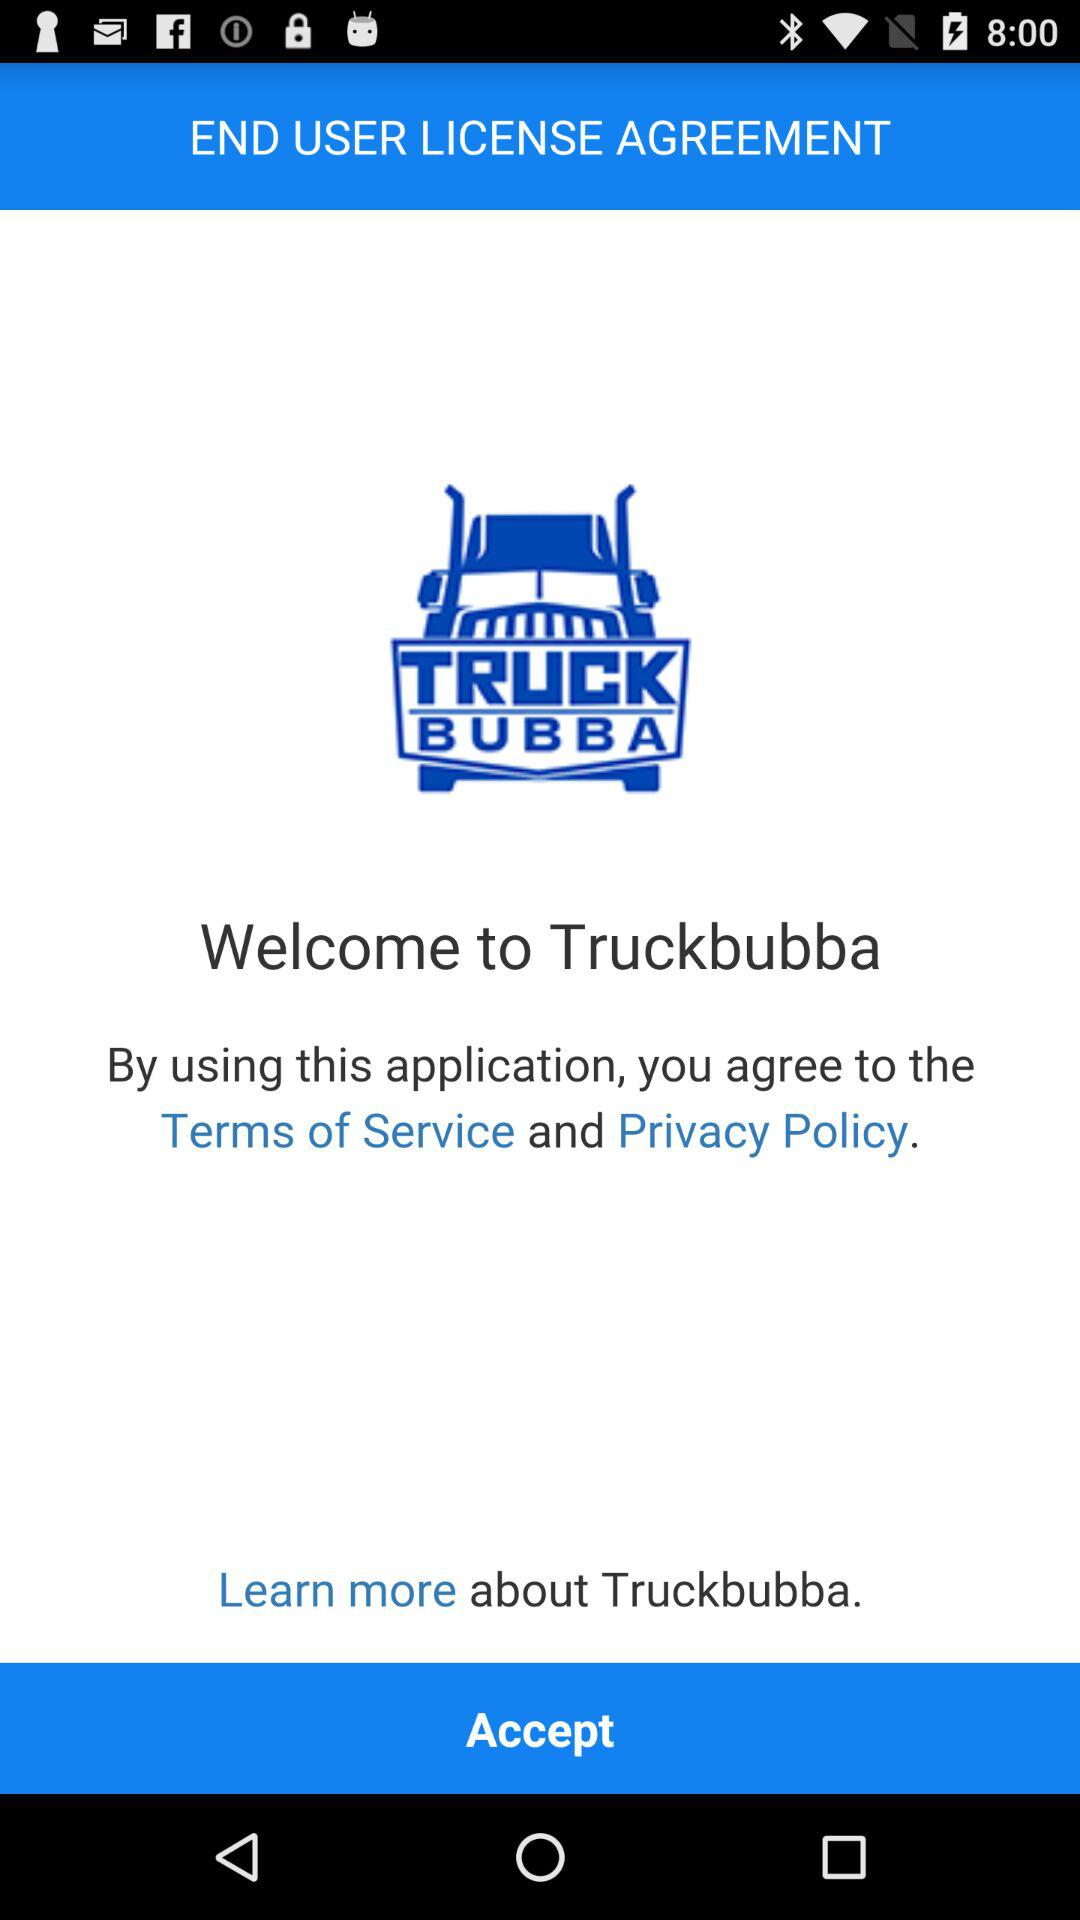What is the name of the application? The application name is "Truckbubba". 